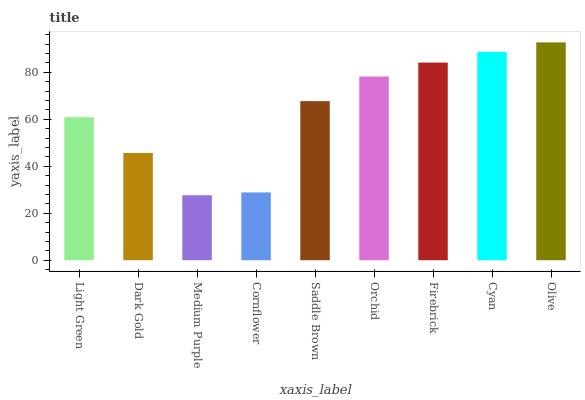Is Medium Purple the minimum?
Answer yes or no. Yes. Is Olive the maximum?
Answer yes or no. Yes. Is Dark Gold the minimum?
Answer yes or no. No. Is Dark Gold the maximum?
Answer yes or no. No. Is Light Green greater than Dark Gold?
Answer yes or no. Yes. Is Dark Gold less than Light Green?
Answer yes or no. Yes. Is Dark Gold greater than Light Green?
Answer yes or no. No. Is Light Green less than Dark Gold?
Answer yes or no. No. Is Saddle Brown the high median?
Answer yes or no. Yes. Is Saddle Brown the low median?
Answer yes or no. Yes. Is Cornflower the high median?
Answer yes or no. No. Is Orchid the low median?
Answer yes or no. No. 